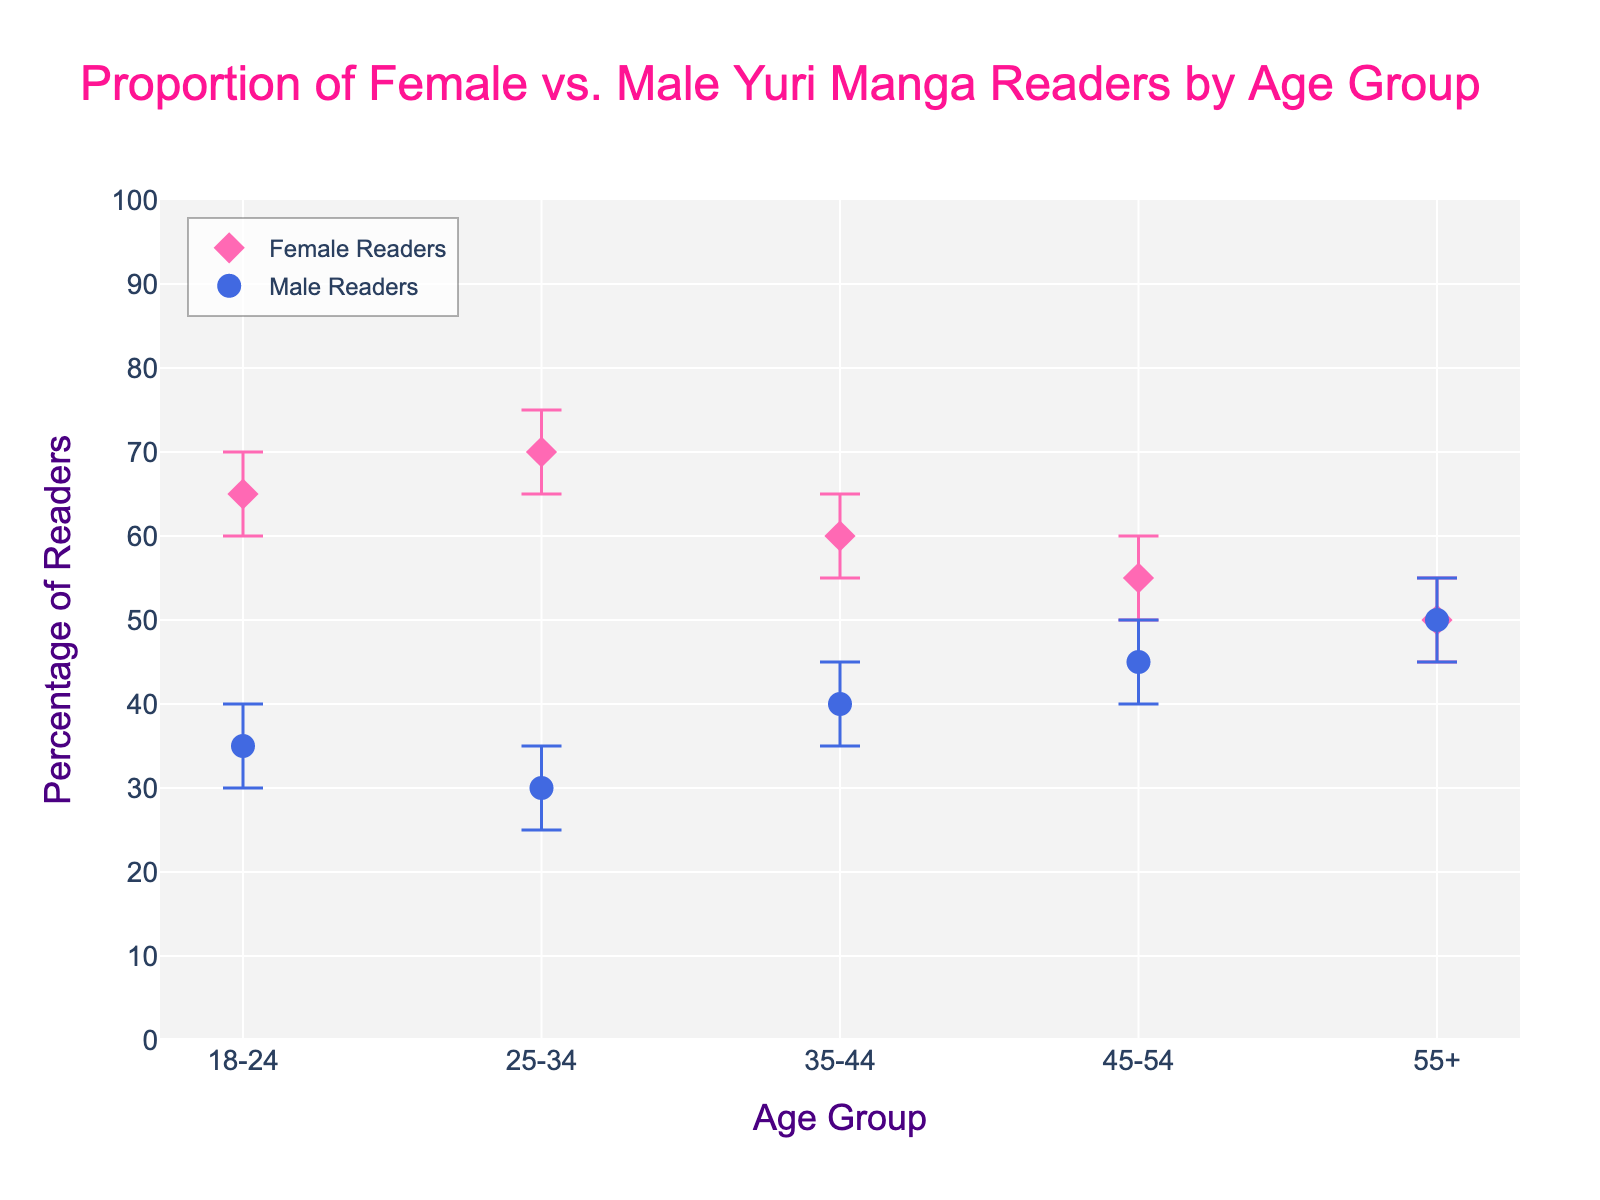What is the title of the figure? The title is found at the top of the figure, providing a description of what the figure represents. Here, it says "Proportion of Female vs. Male Yuri Manga Readers by Age Group."
Answer: Proportion of Female vs. Male Yuri Manga Readers by Age Group How many age groups are displayed in the figure? There are labels along the x-axis representing different age groups. By counting these labels, we find that there are five age groups displayed.
Answer: Five In which age group is the percentage of female readers the highest? Look at the y-values (percentage) of the pink diamond markers representing female readers. The highest value corresponds to the age group 25-34.
Answer: 25-34 What is the percentage of male readers in the age group 45-54? Identify the blue circle marker corresponding to the age group 45-54 along the x-axis, then read its y-value which represents the percentage of male readers.
Answer: 45% Which age group has the smallest difference between percentages of female and male readers? For each age group, subtract the percentage of male readers from the percentage of female readers. The age group with the smallest result is 55+ because 50% - 50% = 0%.
Answer: 55+ What are the confidence interval bounds for female readers in the 35-44 age group? For the age group 35-44, look at the error bars on the pink diamond marker representing female readers. The lower bound is 55% and the upper bound is 65%.
Answer: Lower: 55%, Upper: 65% How do the confidence intervals for male readers in the 25-34 age group compare to those in the 18-24 age group? For male readers, compare the error bars' lower and upper bounds for the age groups 25-34 (25% to 35%) and 18-24 (30% to 40%). The intervals for 25-34 (10% range) are narrower than those for 18-24 (10% range, but different values).
Answer: 25-34: 25% to 35%, 18-24: 30% to 40% Which age group shows the most balanced proportion of female to male readers? Look for the age group where the percentages of female and male readers are closest to each other. The 55+ age group has 50% for both female and male readers.
Answer: 55+ What is the average percentage of female readers across all age groups? Sum the percentages of female readers for all age groups (65% + 70% + 60% + 55% + 50%) and then divide by the number of age groups (5). The calculation is (65 + 70 + 60 + 55 + 50)/5 = 60%.
Answer: 60% How does the trend in female reader percentages change with age? Observe the pink diamond markers along the x-axis, which represent different age groups. Notice how the y-values (percentages) decrease as the age groups progress from 18-24 to 55+. Female reader percentages decline with age.
Answer: Decline with age 